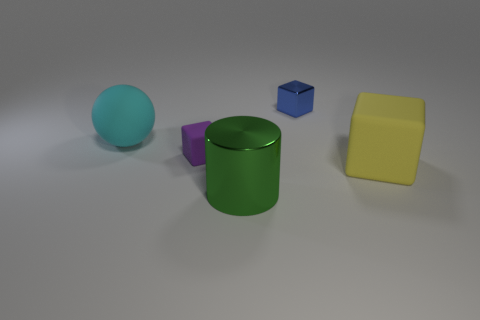How many metallic things are either big red objects or yellow things?
Your answer should be compact. 0. The other small object that is the same shape as the blue thing is what color?
Provide a succinct answer. Purple. Is there a rubber block?
Your answer should be compact. Yes. Does the small object to the left of the shiny cylinder have the same material as the tiny block on the right side of the green metal cylinder?
Keep it short and to the point. No. What number of objects are either rubber blocks to the left of the big yellow matte thing or small things in front of the large cyan rubber ball?
Your answer should be very brief. 1. There is a metal thing in front of the blue object; is its color the same as the rubber block that is behind the big rubber block?
Keep it short and to the point. No. The rubber object that is both on the left side of the small blue metallic cube and right of the large cyan thing has what shape?
Ensure brevity in your answer.  Cube. What is the color of the metal cylinder that is the same size as the rubber ball?
Ensure brevity in your answer.  Green. Are there any big things of the same color as the small matte thing?
Your answer should be compact. No. There is a matte block right of the tiny purple object; does it have the same size as the object in front of the large yellow cube?
Provide a short and direct response. Yes. 